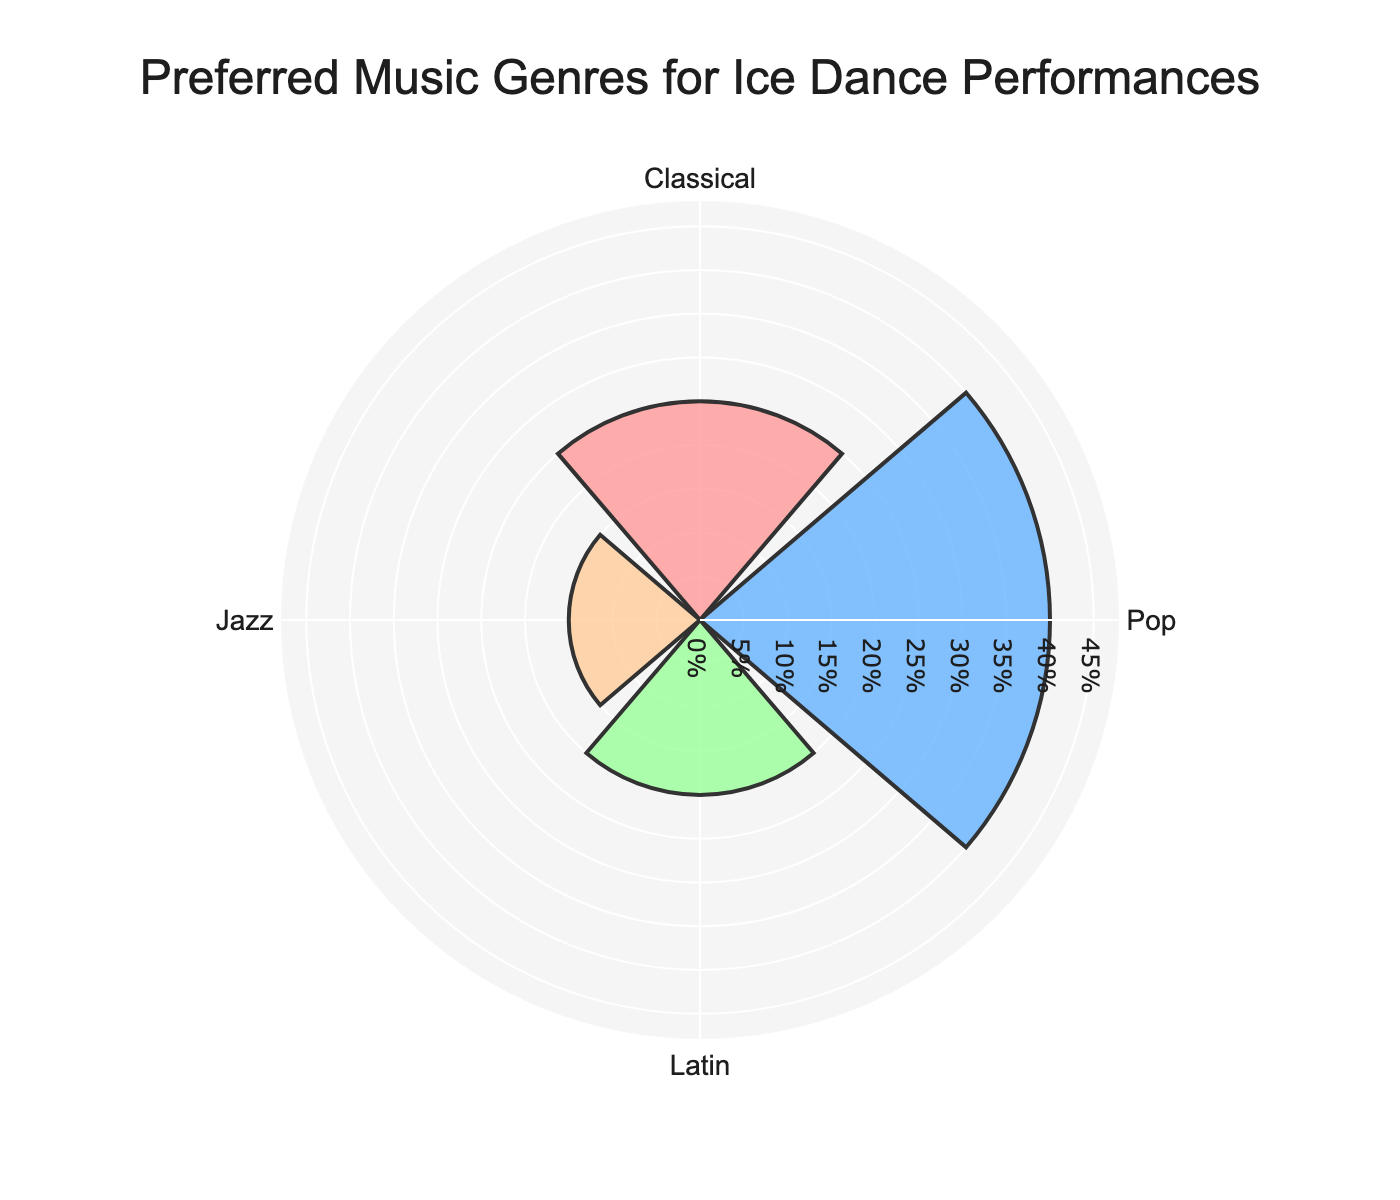What is the title of the figure? The title is typically located centrally at the top of the figure and gives us an overview of what the figure represents. In this case, it informs us about the preferred music genres for ice dance performances.
Answer: Preferred Music Genres for Ice Dance Performances How many music genres are represented in the figure? By examining the labeled segments in the rose chart, we can count the number of distinct music genres. Each genre is represented as one segment.
Answer: Four Which music genre has the highest percentage of student preference? Looking at the lengths of the segments or bars extending from the center of the rose chart, the longest segment corresponds to the highest percentage.
Answer: Pop What is the combined percentage of students preferring Classical and Jazz genres? First, identify the percentages for Classical and Jazz from the segments. Then, add these percentages together: 25% (Classical) + 15% (Jazz).
Answer: 40% How does the percentage of students preferring Latin compare to that of Jazz? Examine the lengths of the segments for both Latin and Jazz, then compare their percentages. Latin has a percentage of 20%, while Jazz has 15%.
Answer: Latin has a higher percentage than Jazz What is the average percentage of student preference across all music genres? Sum all the percentages (25% + 40% + 20% + 15%) and divide by the number of genres (4). The calculation is (100 / 4).
Answer: 25% Which genre is preferred by the least percentage of students, and what is that percentage? Identify the segment with the shortest length, corresponding to the smallest percentage.
Answer: Jazz, 15% What is the difference in student preference percentage between Pop and Classical genres? Identify the percentages for Pop (40%) and Classical (25%), then subtract the smaller percentage from the larger. The calculation is 40% - 25%.
Answer: 15% Is there a genre that exactly matches the overall average preference percentage? First, calculate the overall average (25%). Then, compare this value with the percentages of each genre.
Answer: Yes, Classical matches the average of 25% What would be the total percentage if Classical, Latin, and Jazz were combined? Sum the percentages of Classical (25%), Latin (20%), and Jazz (15%). The calculation is 25% + 20% + 15%.
Answer: 60% 